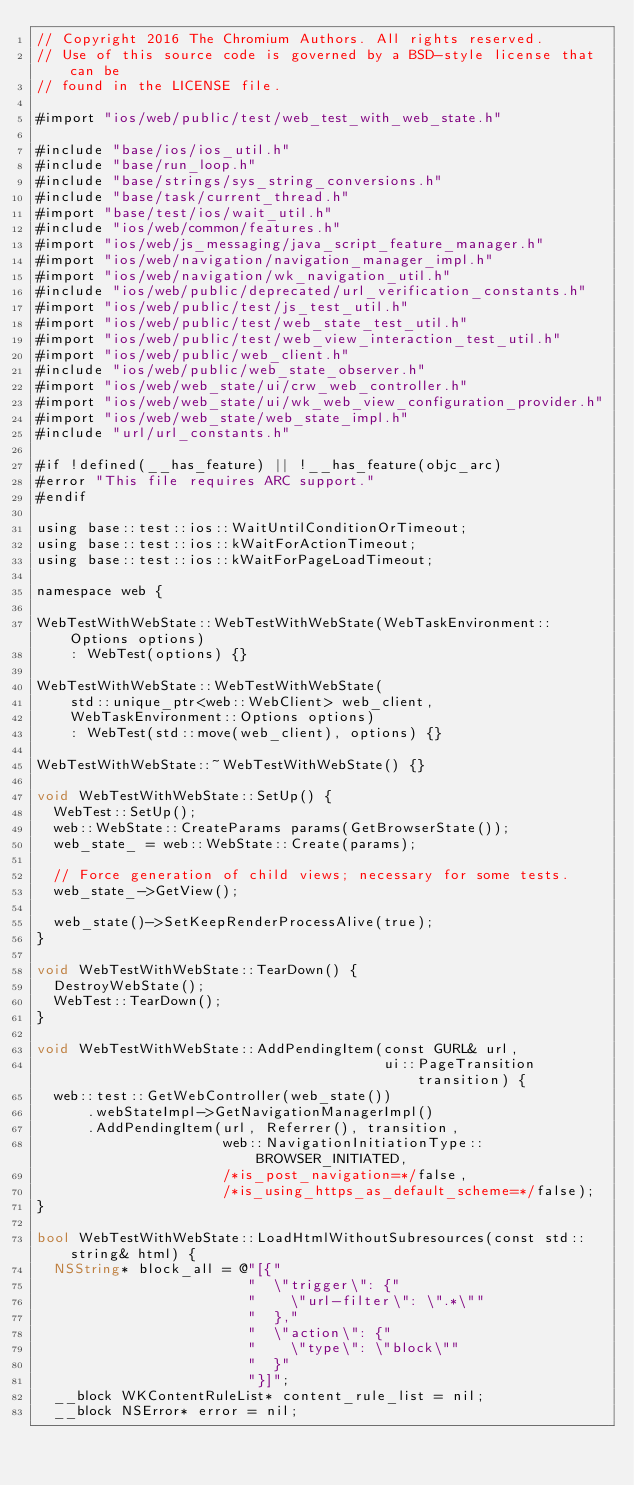<code> <loc_0><loc_0><loc_500><loc_500><_ObjectiveC_>// Copyright 2016 The Chromium Authors. All rights reserved.
// Use of this source code is governed by a BSD-style license that can be
// found in the LICENSE file.

#import "ios/web/public/test/web_test_with_web_state.h"

#include "base/ios/ios_util.h"
#include "base/run_loop.h"
#include "base/strings/sys_string_conversions.h"
#include "base/task/current_thread.h"
#import "base/test/ios/wait_util.h"
#include "ios/web/common/features.h"
#import "ios/web/js_messaging/java_script_feature_manager.h"
#import "ios/web/navigation/navigation_manager_impl.h"
#import "ios/web/navigation/wk_navigation_util.h"
#include "ios/web/public/deprecated/url_verification_constants.h"
#import "ios/web/public/test/js_test_util.h"
#import "ios/web/public/test/web_state_test_util.h"
#import "ios/web/public/test/web_view_interaction_test_util.h"
#import "ios/web/public/web_client.h"
#include "ios/web/public/web_state_observer.h"
#import "ios/web/web_state/ui/crw_web_controller.h"
#import "ios/web/web_state/ui/wk_web_view_configuration_provider.h"
#import "ios/web/web_state/web_state_impl.h"
#include "url/url_constants.h"

#if !defined(__has_feature) || !__has_feature(objc_arc)
#error "This file requires ARC support."
#endif

using base::test::ios::WaitUntilConditionOrTimeout;
using base::test::ios::kWaitForActionTimeout;
using base::test::ios::kWaitForPageLoadTimeout;

namespace web {

WebTestWithWebState::WebTestWithWebState(WebTaskEnvironment::Options options)
    : WebTest(options) {}

WebTestWithWebState::WebTestWithWebState(
    std::unique_ptr<web::WebClient> web_client,
    WebTaskEnvironment::Options options)
    : WebTest(std::move(web_client), options) {}

WebTestWithWebState::~WebTestWithWebState() {}

void WebTestWithWebState::SetUp() {
  WebTest::SetUp();
  web::WebState::CreateParams params(GetBrowserState());
  web_state_ = web::WebState::Create(params);

  // Force generation of child views; necessary for some tests.
  web_state_->GetView();

  web_state()->SetKeepRenderProcessAlive(true);
}

void WebTestWithWebState::TearDown() {
  DestroyWebState();
  WebTest::TearDown();
}

void WebTestWithWebState::AddPendingItem(const GURL& url,
                                         ui::PageTransition transition) {
  web::test::GetWebController(web_state())
      .webStateImpl->GetNavigationManagerImpl()
      .AddPendingItem(url, Referrer(), transition,
                      web::NavigationInitiationType::BROWSER_INITIATED,
                      /*is_post_navigation=*/false,
                      /*is_using_https_as_default_scheme=*/false);
}

bool WebTestWithWebState::LoadHtmlWithoutSubresources(const std::string& html) {
  NSString* block_all = @"[{"
                         "  \"trigger\": {"
                         "    \"url-filter\": \".*\""
                         "  },"
                         "  \"action\": {"
                         "    \"type\": \"block\""
                         "  }"
                         "}]";
  __block WKContentRuleList* content_rule_list = nil;
  __block NSError* error = nil;</code> 